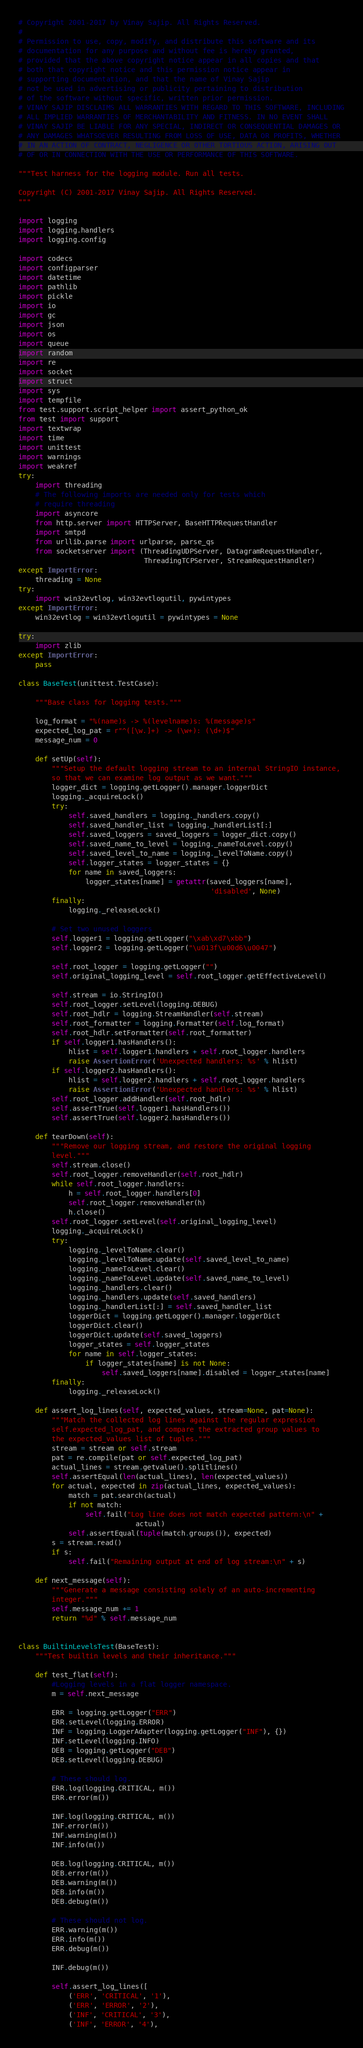Convert code to text. <code><loc_0><loc_0><loc_500><loc_500><_Python_># Copyright 2001-2017 by Vinay Sajip. All Rights Reserved.
#
# Permission to use, copy, modify, and distribute this software and its
# documentation for any purpose and without fee is hereby granted,
# provided that the above copyright notice appear in all copies and that
# both that copyright notice and this permission notice appear in
# supporting documentation, and that the name of Vinay Sajip
# not be used in advertising or publicity pertaining to distribution
# of the software without specific, written prior permission.
# VINAY SAJIP DISCLAIMS ALL WARRANTIES WITH REGARD TO THIS SOFTWARE, INCLUDING
# ALL IMPLIED WARRANTIES OF MERCHANTABILITY AND FITNESS. IN NO EVENT SHALL
# VINAY SAJIP BE LIABLE FOR ANY SPECIAL, INDIRECT OR CONSEQUENTIAL DAMAGES OR
# ANY DAMAGES WHATSOEVER RESULTING FROM LOSS OF USE, DATA OR PROFITS, WHETHER
# IN AN ACTION OF CONTRACT, NEGLIGENCE OR OTHER TORTIOUS ACTION, ARISING OUT
# OF OR IN CONNECTION WITH THE USE OR PERFORMANCE OF THIS SOFTWARE.

"""Test harness for the logging module. Run all tests.

Copyright (C) 2001-2017 Vinay Sajip. All Rights Reserved.
"""

import logging
import logging.handlers
import logging.config

import codecs
import configparser
import datetime
import pathlib
import pickle
import io
import gc
import json
import os
import queue
import random
import re
import socket
import struct
import sys
import tempfile
from test.support.script_helper import assert_python_ok
from test import support
import textwrap
import time
import unittest
import warnings
import weakref
try:
    import threading
    # The following imports are needed only for tests which
    # require threading
    import asyncore
    from http.server import HTTPServer, BaseHTTPRequestHandler
    import smtpd
    from urllib.parse import urlparse, parse_qs
    from socketserver import (ThreadingUDPServer, DatagramRequestHandler,
                              ThreadingTCPServer, StreamRequestHandler)
except ImportError:
    threading = None
try:
    import win32evtlog, win32evtlogutil, pywintypes
except ImportError:
    win32evtlog = win32evtlogutil = pywintypes = None

try:
    import zlib
except ImportError:
    pass

class BaseTest(unittest.TestCase):

    """Base class for logging tests."""

    log_format = "%(name)s -> %(levelname)s: %(message)s"
    expected_log_pat = r"^([\w.]+) -> (\w+): (\d+)$"
    message_num = 0

    def setUp(self):
        """Setup the default logging stream to an internal StringIO instance,
        so that we can examine log output as we want."""
        logger_dict = logging.getLogger().manager.loggerDict
        logging._acquireLock()
        try:
            self.saved_handlers = logging._handlers.copy()
            self.saved_handler_list = logging._handlerList[:]
            self.saved_loggers = saved_loggers = logger_dict.copy()
            self.saved_name_to_level = logging._nameToLevel.copy()
            self.saved_level_to_name = logging._levelToName.copy()
            self.logger_states = logger_states = {}
            for name in saved_loggers:
                logger_states[name] = getattr(saved_loggers[name],
                                              'disabled', None)
        finally:
            logging._releaseLock()

        # Set two unused loggers
        self.logger1 = logging.getLogger("\xab\xd7\xbb")
        self.logger2 = logging.getLogger("\u013f\u00d6\u0047")

        self.root_logger = logging.getLogger("")
        self.original_logging_level = self.root_logger.getEffectiveLevel()

        self.stream = io.StringIO()
        self.root_logger.setLevel(logging.DEBUG)
        self.root_hdlr = logging.StreamHandler(self.stream)
        self.root_formatter = logging.Formatter(self.log_format)
        self.root_hdlr.setFormatter(self.root_formatter)
        if self.logger1.hasHandlers():
            hlist = self.logger1.handlers + self.root_logger.handlers
            raise AssertionError('Unexpected handlers: %s' % hlist)
        if self.logger2.hasHandlers():
            hlist = self.logger2.handlers + self.root_logger.handlers
            raise AssertionError('Unexpected handlers: %s' % hlist)
        self.root_logger.addHandler(self.root_hdlr)
        self.assertTrue(self.logger1.hasHandlers())
        self.assertTrue(self.logger2.hasHandlers())

    def tearDown(self):
        """Remove our logging stream, and restore the original logging
        level."""
        self.stream.close()
        self.root_logger.removeHandler(self.root_hdlr)
        while self.root_logger.handlers:
            h = self.root_logger.handlers[0]
            self.root_logger.removeHandler(h)
            h.close()
        self.root_logger.setLevel(self.original_logging_level)
        logging._acquireLock()
        try:
            logging._levelToName.clear()
            logging._levelToName.update(self.saved_level_to_name)
            logging._nameToLevel.clear()
            logging._nameToLevel.update(self.saved_name_to_level)
            logging._handlers.clear()
            logging._handlers.update(self.saved_handlers)
            logging._handlerList[:] = self.saved_handler_list
            loggerDict = logging.getLogger().manager.loggerDict
            loggerDict.clear()
            loggerDict.update(self.saved_loggers)
            logger_states = self.logger_states
            for name in self.logger_states:
                if logger_states[name] is not None:
                    self.saved_loggers[name].disabled = logger_states[name]
        finally:
            logging._releaseLock()

    def assert_log_lines(self, expected_values, stream=None, pat=None):
        """Match the collected log lines against the regular expression
        self.expected_log_pat, and compare the extracted group values to
        the expected_values list of tuples."""
        stream = stream or self.stream
        pat = re.compile(pat or self.expected_log_pat)
        actual_lines = stream.getvalue().splitlines()
        self.assertEqual(len(actual_lines), len(expected_values))
        for actual, expected in zip(actual_lines, expected_values):
            match = pat.search(actual)
            if not match:
                self.fail("Log line does not match expected pattern:\n" +
                            actual)
            self.assertEqual(tuple(match.groups()), expected)
        s = stream.read()
        if s:
            self.fail("Remaining output at end of log stream:\n" + s)

    def next_message(self):
        """Generate a message consisting solely of an auto-incrementing
        integer."""
        self.message_num += 1
        return "%d" % self.message_num


class BuiltinLevelsTest(BaseTest):
    """Test builtin levels and their inheritance."""

    def test_flat(self):
        #Logging levels in a flat logger namespace.
        m = self.next_message

        ERR = logging.getLogger("ERR")
        ERR.setLevel(logging.ERROR)
        INF = logging.LoggerAdapter(logging.getLogger("INF"), {})
        INF.setLevel(logging.INFO)
        DEB = logging.getLogger("DEB")
        DEB.setLevel(logging.DEBUG)

        # These should log.
        ERR.log(logging.CRITICAL, m())
        ERR.error(m())

        INF.log(logging.CRITICAL, m())
        INF.error(m())
        INF.warning(m())
        INF.info(m())

        DEB.log(logging.CRITICAL, m())
        DEB.error(m())
        DEB.warning(m())
        DEB.info(m())
        DEB.debug(m())

        # These should not log.
        ERR.warning(m())
        ERR.info(m())
        ERR.debug(m())

        INF.debug(m())

        self.assert_log_lines([
            ('ERR', 'CRITICAL', '1'),
            ('ERR', 'ERROR', '2'),
            ('INF', 'CRITICAL', '3'),
            ('INF', 'ERROR', '4'),</code> 